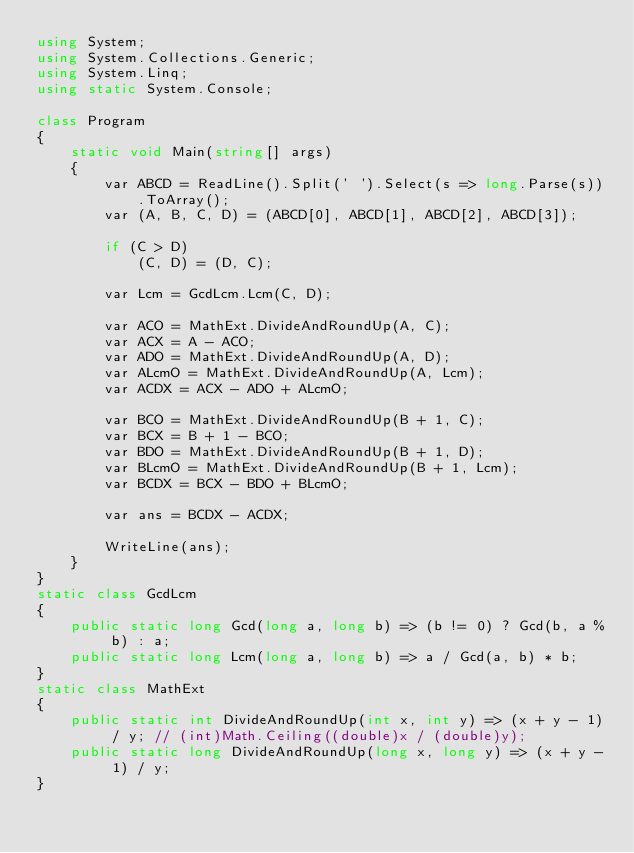<code> <loc_0><loc_0><loc_500><loc_500><_C#_>using System;
using System.Collections.Generic;
using System.Linq;
using static System.Console;

class Program
{
    static void Main(string[] args)
    {
        var ABCD = ReadLine().Split(' ').Select(s => long.Parse(s)).ToArray();
        var (A, B, C, D) = (ABCD[0], ABCD[1], ABCD[2], ABCD[3]);

        if (C > D)
            (C, D) = (D, C);

        var Lcm = GcdLcm.Lcm(C, D);

        var ACO = MathExt.DivideAndRoundUp(A, C);
        var ACX = A - ACO;
        var ADO = MathExt.DivideAndRoundUp(A, D);
        var ALcmO = MathExt.DivideAndRoundUp(A, Lcm);
        var ACDX = ACX - ADO + ALcmO;

        var BCO = MathExt.DivideAndRoundUp(B + 1, C);
        var BCX = B + 1 - BCO;
        var BDO = MathExt.DivideAndRoundUp(B + 1, D);
        var BLcmO = MathExt.DivideAndRoundUp(B + 1, Lcm);
        var BCDX = BCX - BDO + BLcmO;

        var ans = BCDX - ACDX;

        WriteLine(ans);
    }
}
static class GcdLcm
{
    public static long Gcd(long a, long b) => (b != 0) ? Gcd(b, a % b) : a;
    public static long Lcm(long a, long b) => a / Gcd(a, b) * b;
}
static class MathExt
{
    public static int DivideAndRoundUp(int x, int y) => (x + y - 1) / y; // (int)Math.Ceiling((double)x / (double)y);
    public static long DivideAndRoundUp(long x, long y) => (x + y - 1) / y;
}
</code> 